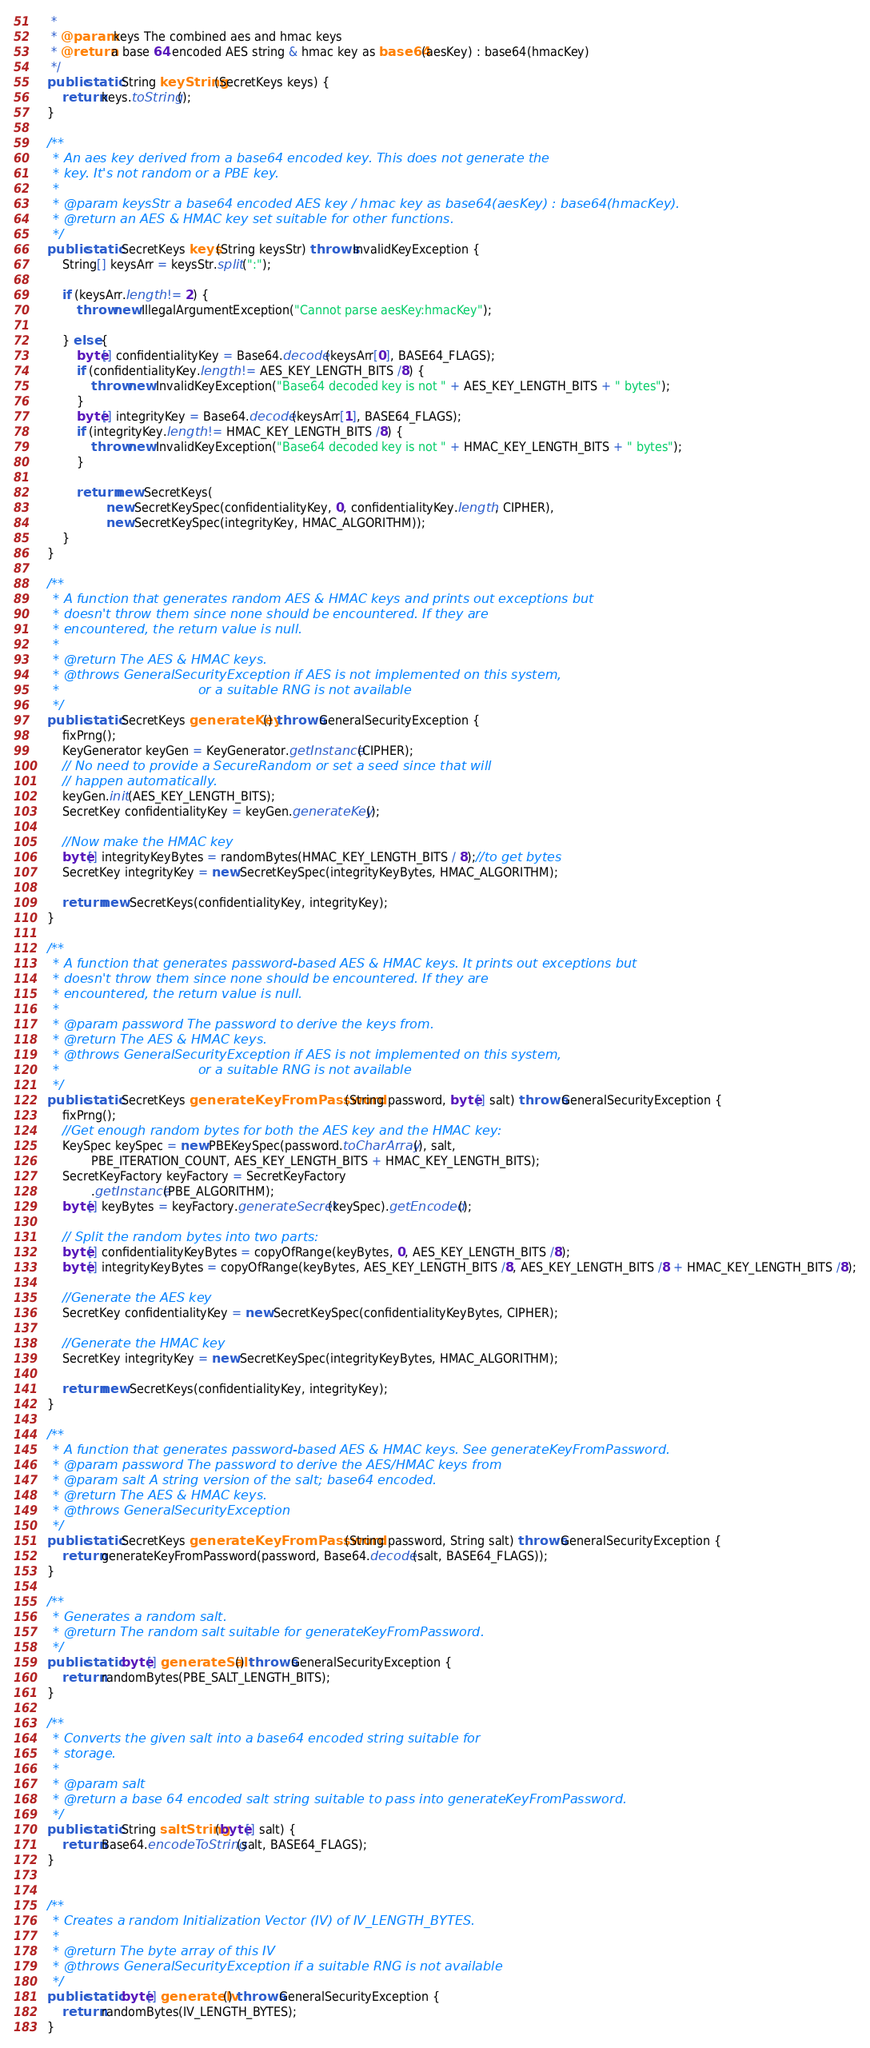Convert code to text. <code><loc_0><loc_0><loc_500><loc_500><_Java_>     *
     * @param keys The combined aes and hmac keys
     * @return a base 64 encoded AES string & hmac key as base64(aesKey) : base64(hmacKey)
     */
    public static String keyString(SecretKeys keys) {
        return keys.toString();
    }

    /**
     * An aes key derived from a base64 encoded key. This does not generate the
     * key. It's not random or a PBE key.
     *
     * @param keysStr a base64 encoded AES key / hmac key as base64(aesKey) : base64(hmacKey).
     * @return an AES & HMAC key set suitable for other functions.
     */
    public static SecretKeys keys(String keysStr) throws InvalidKeyException {
        String[] keysArr = keysStr.split(":");

        if (keysArr.length != 2) {
            throw new IllegalArgumentException("Cannot parse aesKey:hmacKey");

        } else {
            byte[] confidentialityKey = Base64.decode(keysArr[0], BASE64_FLAGS);
            if (confidentialityKey.length != AES_KEY_LENGTH_BITS /8) {
                throw new InvalidKeyException("Base64 decoded key is not " + AES_KEY_LENGTH_BITS + " bytes");
            }
            byte[] integrityKey = Base64.decode(keysArr[1], BASE64_FLAGS);
            if (integrityKey.length != HMAC_KEY_LENGTH_BITS /8) {
                throw new InvalidKeyException("Base64 decoded key is not " + HMAC_KEY_LENGTH_BITS + " bytes");
            }

            return new SecretKeys(
                    new SecretKeySpec(confidentialityKey, 0, confidentialityKey.length, CIPHER),
                    new SecretKeySpec(integrityKey, HMAC_ALGORITHM));
        }
    }

    /**
     * A function that generates random AES & HMAC keys and prints out exceptions but
     * doesn't throw them since none should be encountered. If they are
     * encountered, the return value is null.
     *
     * @return The AES & HMAC keys.
     * @throws GeneralSecurityException if AES is not implemented on this system,
     *                                  or a suitable RNG is not available
     */
    public static SecretKeys generateKey() throws GeneralSecurityException {
        fixPrng();
        KeyGenerator keyGen = KeyGenerator.getInstance(CIPHER);
        // No need to provide a SecureRandom or set a seed since that will
        // happen automatically.
        keyGen.init(AES_KEY_LENGTH_BITS);
        SecretKey confidentialityKey = keyGen.generateKey();

        //Now make the HMAC key
        byte[] integrityKeyBytes = randomBytes(HMAC_KEY_LENGTH_BITS / 8);//to get bytes
        SecretKey integrityKey = new SecretKeySpec(integrityKeyBytes, HMAC_ALGORITHM);

        return new SecretKeys(confidentialityKey, integrityKey);
    }

    /**
     * A function that generates password-based AES & HMAC keys. It prints out exceptions but
     * doesn't throw them since none should be encountered. If they are
     * encountered, the return value is null.
     *
     * @param password The password to derive the keys from.
     * @return The AES & HMAC keys.
     * @throws GeneralSecurityException if AES is not implemented on this system,
     *                                  or a suitable RNG is not available
     */
    public static SecretKeys generateKeyFromPassword(String password, byte[] salt) throws GeneralSecurityException {
        fixPrng();
        //Get enough random bytes for both the AES key and the HMAC key:
        KeySpec keySpec = new PBEKeySpec(password.toCharArray(), salt,
                PBE_ITERATION_COUNT, AES_KEY_LENGTH_BITS + HMAC_KEY_LENGTH_BITS);
        SecretKeyFactory keyFactory = SecretKeyFactory
                .getInstance(PBE_ALGORITHM);
        byte[] keyBytes = keyFactory.generateSecret(keySpec).getEncoded();

        // Split the random bytes into two parts:
        byte[] confidentialityKeyBytes = copyOfRange(keyBytes, 0, AES_KEY_LENGTH_BITS /8);
        byte[] integrityKeyBytes = copyOfRange(keyBytes, AES_KEY_LENGTH_BITS /8, AES_KEY_LENGTH_BITS /8 + HMAC_KEY_LENGTH_BITS /8);

        //Generate the AES key
        SecretKey confidentialityKey = new SecretKeySpec(confidentialityKeyBytes, CIPHER);

        //Generate the HMAC key
        SecretKey integrityKey = new SecretKeySpec(integrityKeyBytes, HMAC_ALGORITHM);

        return new SecretKeys(confidentialityKey, integrityKey);
    }

    /**
     * A function that generates password-based AES & HMAC keys. See generateKeyFromPassword.
     * @param password The password to derive the AES/HMAC keys from
     * @param salt A string version of the salt; base64 encoded.
     * @return The AES & HMAC keys.
     * @throws GeneralSecurityException
     */
    public static SecretKeys generateKeyFromPassword(String password, String salt) throws GeneralSecurityException {
        return generateKeyFromPassword(password, Base64.decode(salt, BASE64_FLAGS));
    }

    /**
     * Generates a random salt.
     * @return The random salt suitable for generateKeyFromPassword.
     */
    public static byte[] generateSalt() throws GeneralSecurityException {
        return randomBytes(PBE_SALT_LENGTH_BITS);
    }

    /**
     * Converts the given salt into a base64 encoded string suitable for
     * storage.
     *
     * @param salt
     * @return a base 64 encoded salt string suitable to pass into generateKeyFromPassword.
     */
    public static String saltString(byte[] salt) {
        return Base64.encodeToString(salt, BASE64_FLAGS);
    }


    /**
     * Creates a random Initialization Vector (IV) of IV_LENGTH_BYTES.
     *
     * @return The byte array of this IV
     * @throws GeneralSecurityException if a suitable RNG is not available
     */
    public static byte[] generateIv() throws GeneralSecurityException {
        return randomBytes(IV_LENGTH_BYTES);
    }
</code> 